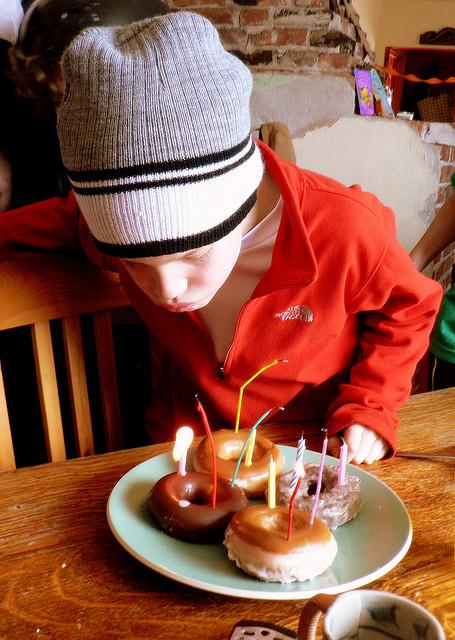What is the boy about to do?

Choices:
A) spit
B) throw up
C) blow candle
D) smell blow candle 